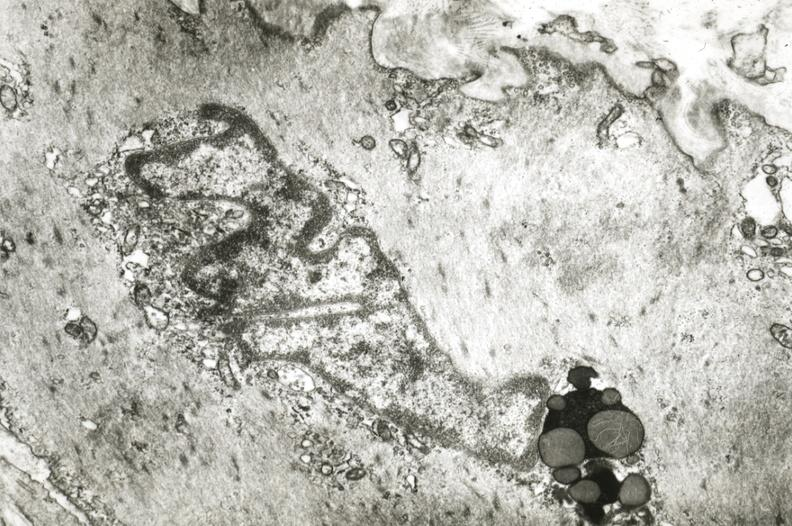s coronary artery present?
Answer the question using a single word or phrase. Yes 